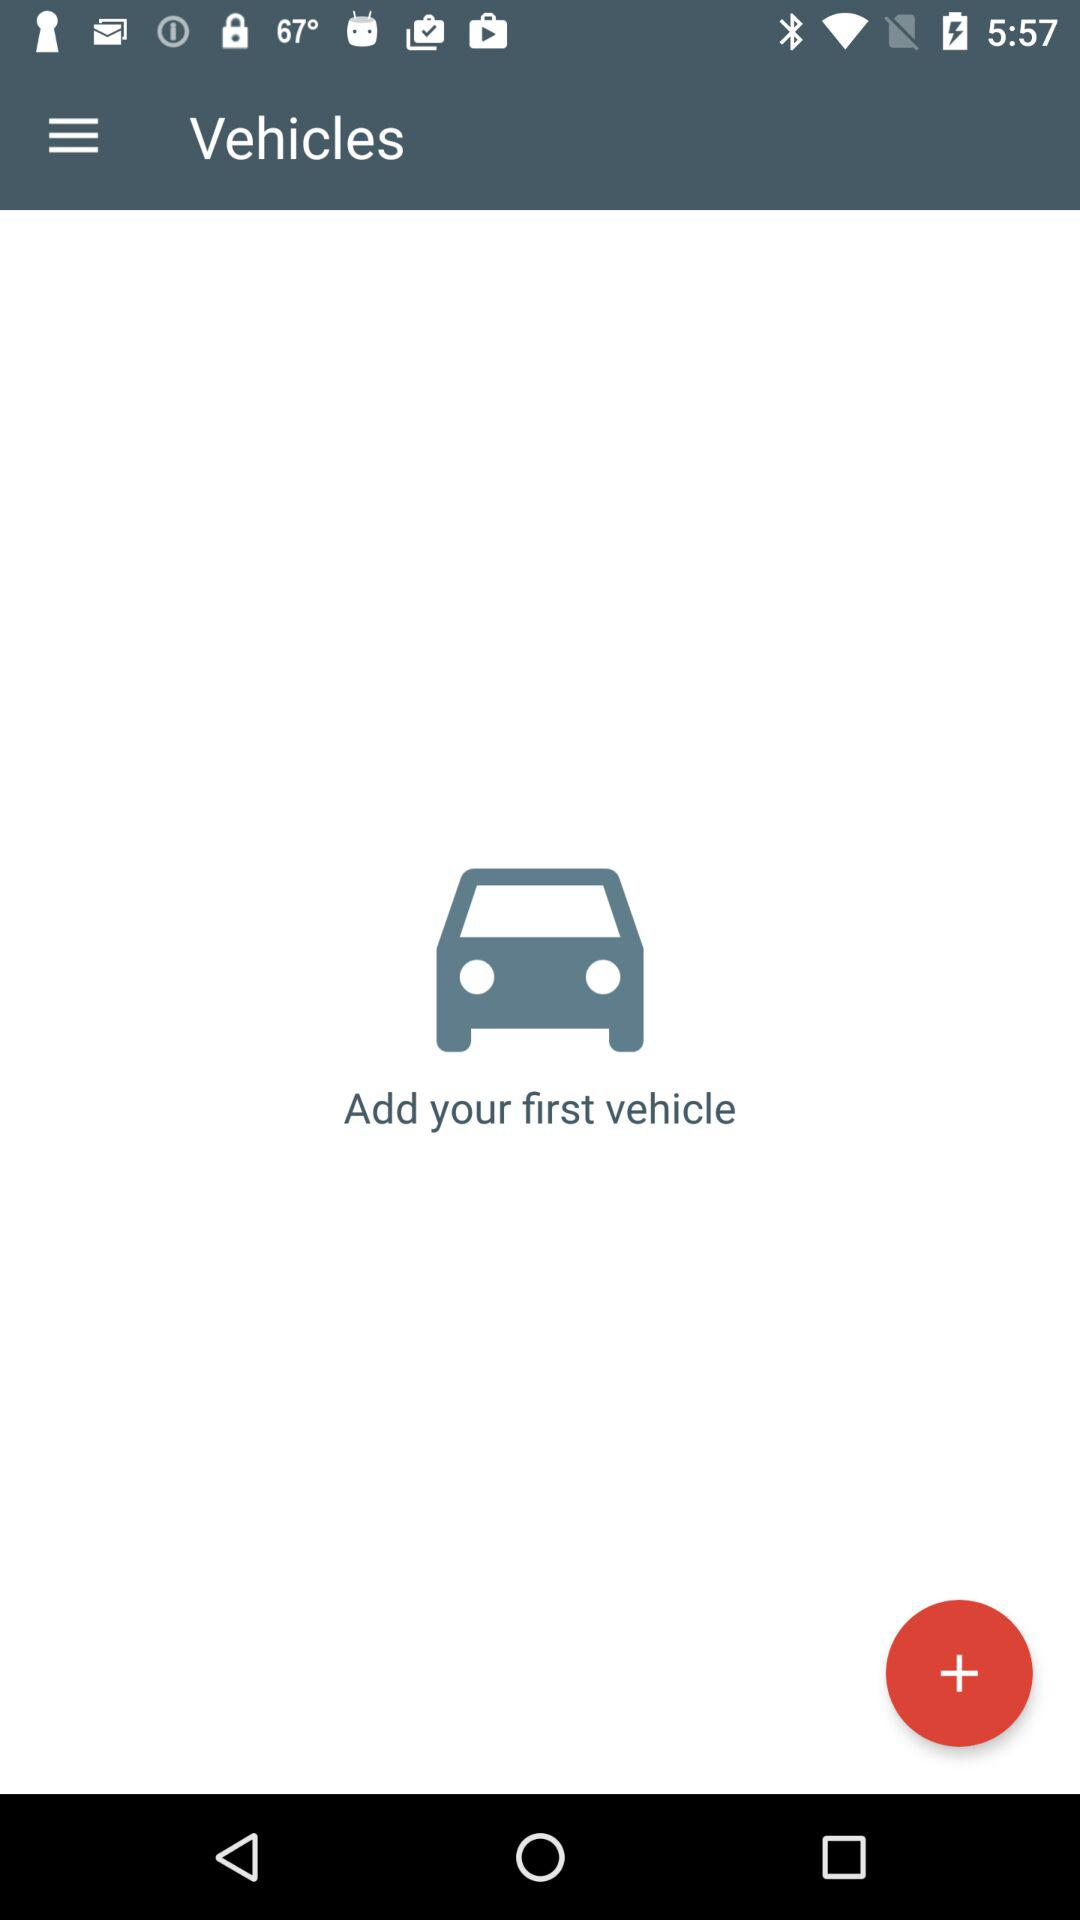How many more vehicles do I need to add to complete the onboarding process?
Answer the question using a single word or phrase. 1 